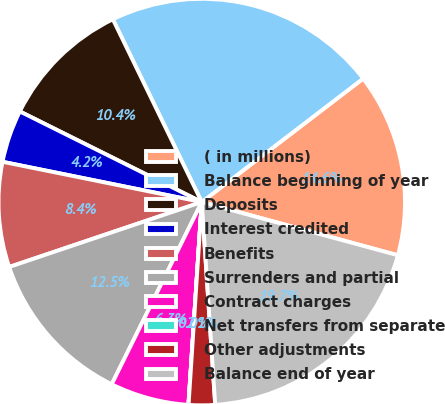Convert chart to OTSL. <chart><loc_0><loc_0><loc_500><loc_500><pie_chart><fcel>( in millions)<fcel>Balance beginning of year<fcel>Deposits<fcel>Interest credited<fcel>Benefits<fcel>Surrenders and partial<fcel>Contract charges<fcel>Net transfers from separate<fcel>Other adjustments<fcel>Balance end of year<nl><fcel>14.61%<fcel>21.81%<fcel>10.44%<fcel>4.18%<fcel>8.35%<fcel>12.52%<fcel>6.26%<fcel>0.01%<fcel>2.09%<fcel>19.73%<nl></chart> 